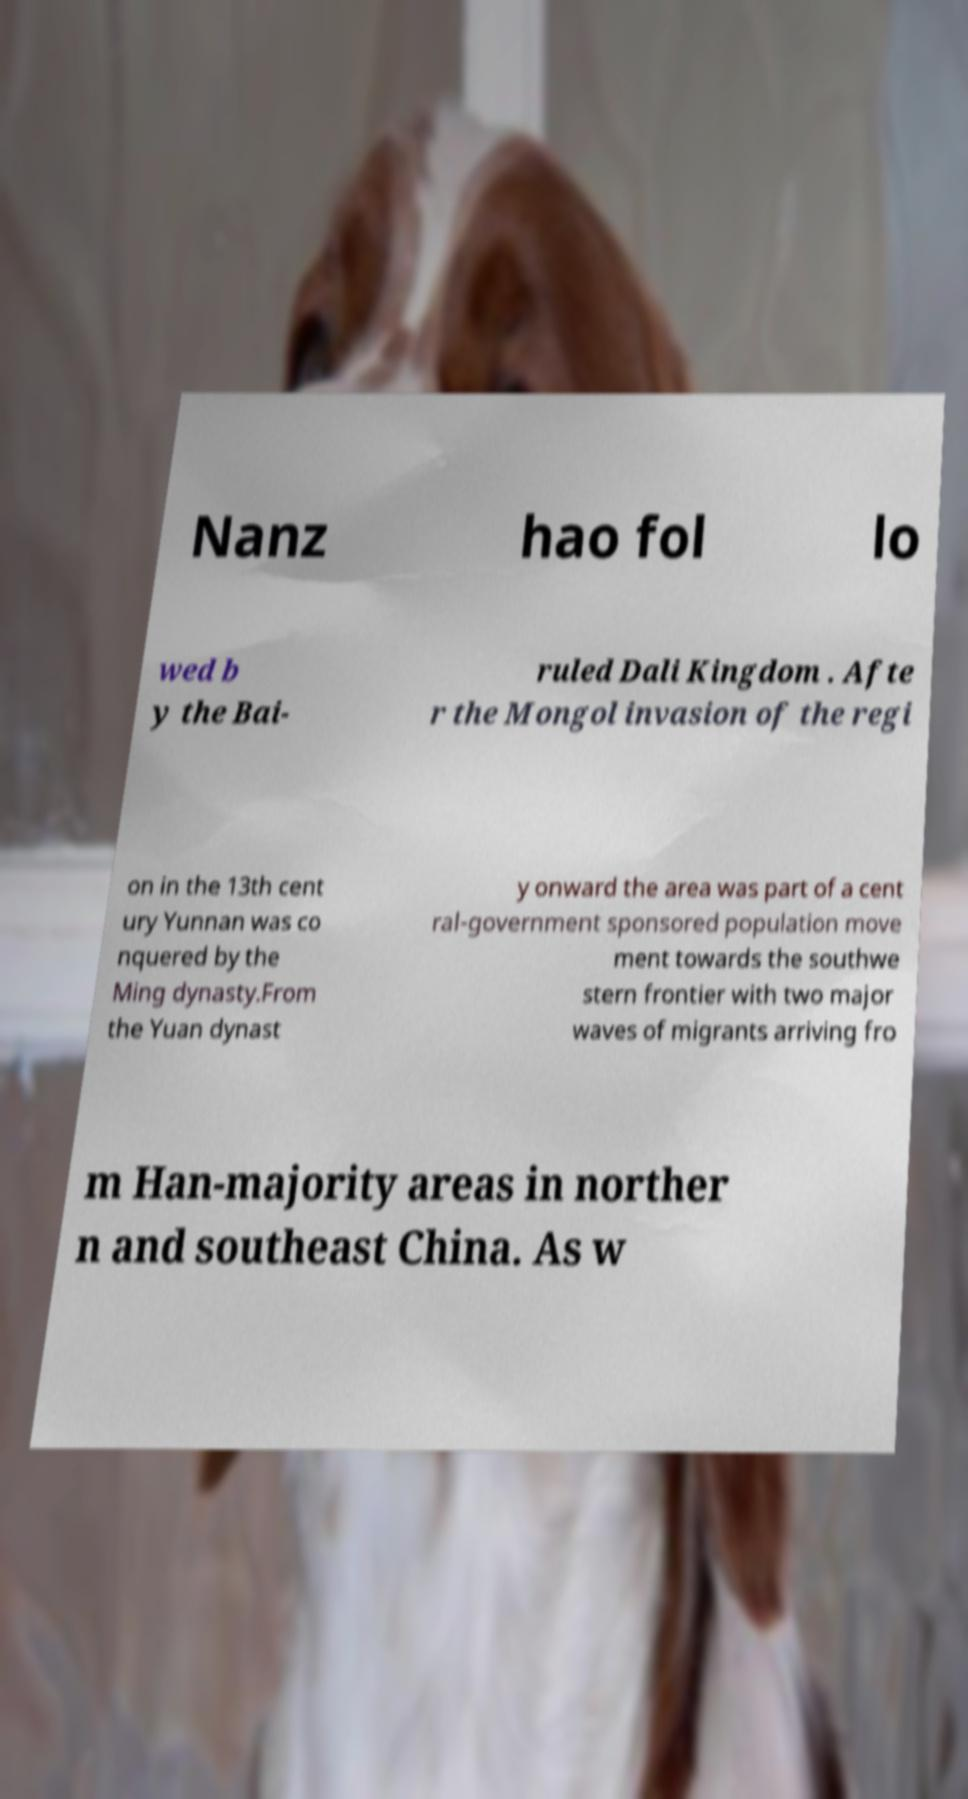Please read and relay the text visible in this image. What does it say? Nanz hao fol lo wed b y the Bai- ruled Dali Kingdom . Afte r the Mongol invasion of the regi on in the 13th cent ury Yunnan was co nquered by the Ming dynasty.From the Yuan dynast y onward the area was part of a cent ral-government sponsored population move ment towards the southwe stern frontier with two major waves of migrants arriving fro m Han-majority areas in norther n and southeast China. As w 